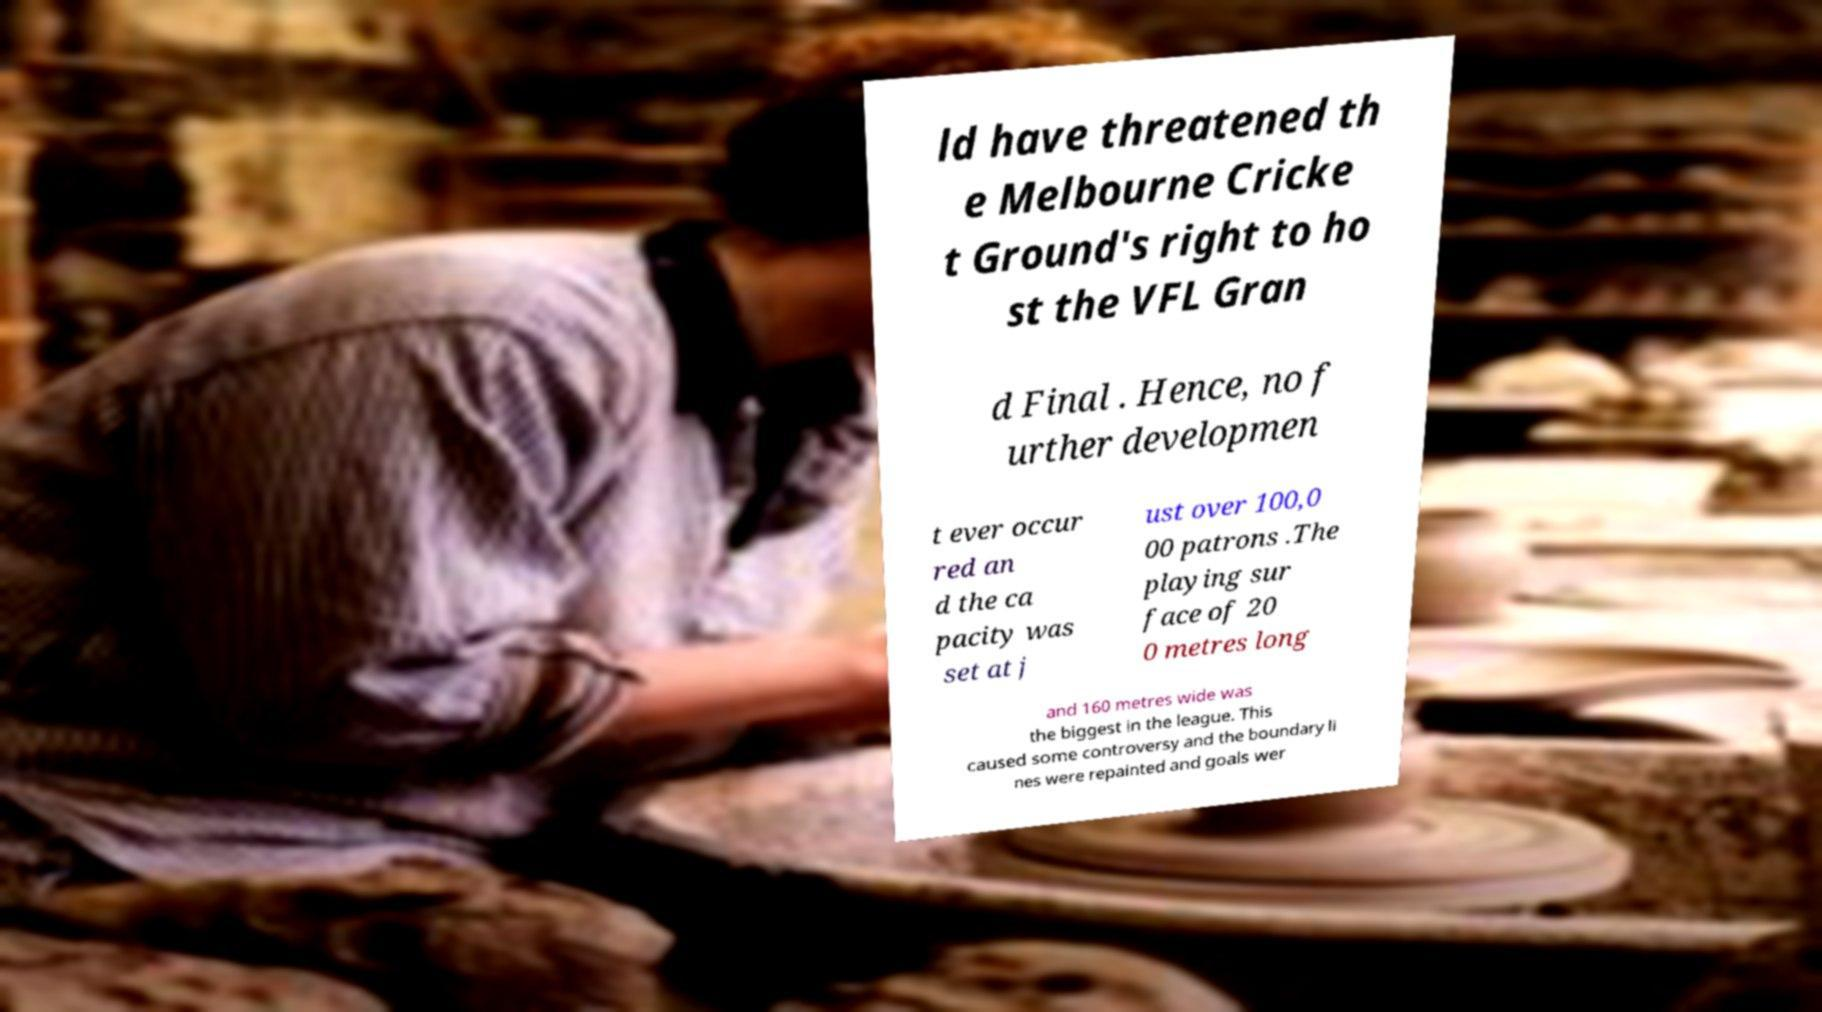Could you assist in decoding the text presented in this image and type it out clearly? ld have threatened th e Melbourne Cricke t Ground's right to ho st the VFL Gran d Final . Hence, no f urther developmen t ever occur red an d the ca pacity was set at j ust over 100,0 00 patrons .The playing sur face of 20 0 metres long and 160 metres wide was the biggest in the league. This caused some controversy and the boundary li nes were repainted and goals wer 